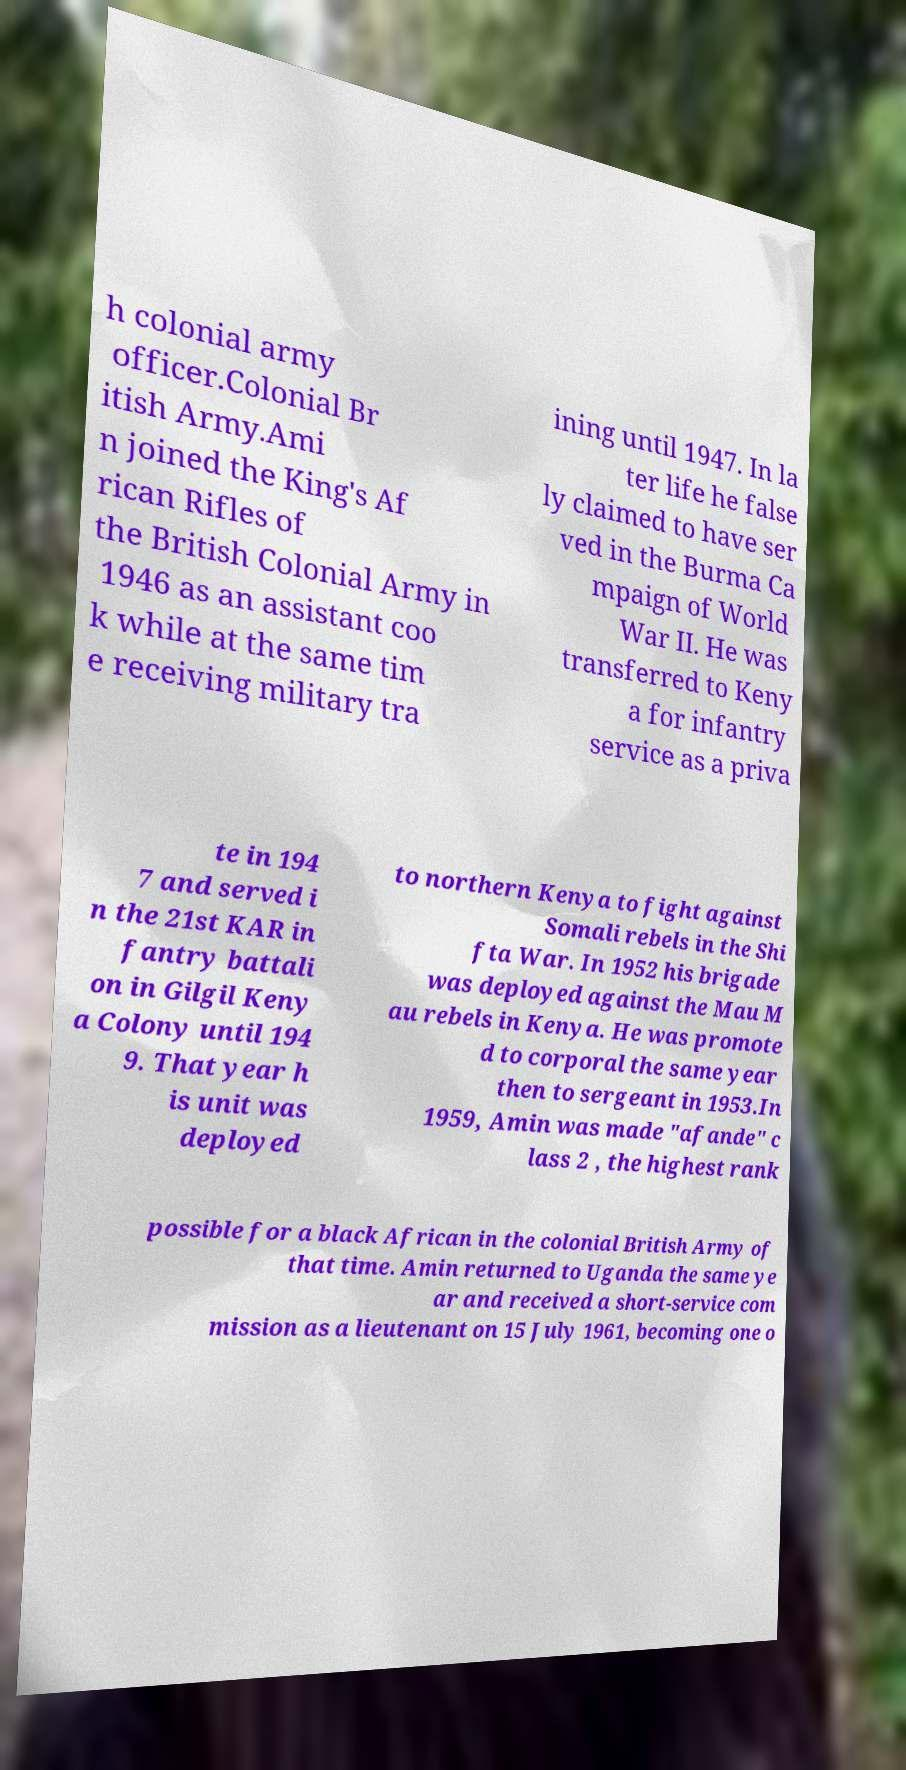For documentation purposes, I need the text within this image transcribed. Could you provide that? h colonial army officer.Colonial Br itish Army.Ami n joined the King's Af rican Rifles of the British Colonial Army in 1946 as an assistant coo k while at the same tim e receiving military tra ining until 1947. In la ter life he false ly claimed to have ser ved in the Burma Ca mpaign of World War II. He was transferred to Keny a for infantry service as a priva te in 194 7 and served i n the 21st KAR in fantry battali on in Gilgil Keny a Colony until 194 9. That year h is unit was deployed to northern Kenya to fight against Somali rebels in the Shi fta War. In 1952 his brigade was deployed against the Mau M au rebels in Kenya. He was promote d to corporal the same year then to sergeant in 1953.In 1959, Amin was made "afande" c lass 2 , the highest rank possible for a black African in the colonial British Army of that time. Amin returned to Uganda the same ye ar and received a short-service com mission as a lieutenant on 15 July 1961, becoming one o 